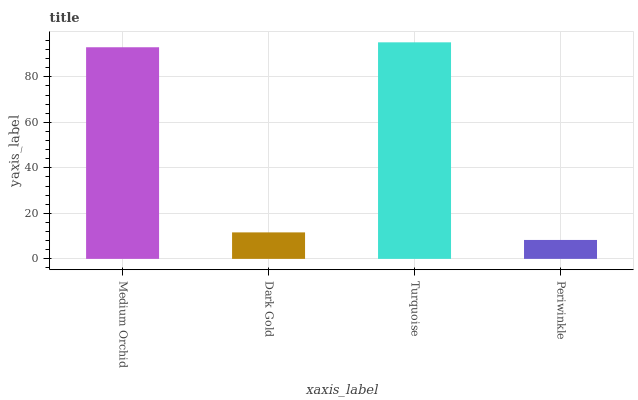Is Dark Gold the minimum?
Answer yes or no. No. Is Dark Gold the maximum?
Answer yes or no. No. Is Medium Orchid greater than Dark Gold?
Answer yes or no. Yes. Is Dark Gold less than Medium Orchid?
Answer yes or no. Yes. Is Dark Gold greater than Medium Orchid?
Answer yes or no. No. Is Medium Orchid less than Dark Gold?
Answer yes or no. No. Is Medium Orchid the high median?
Answer yes or no. Yes. Is Dark Gold the low median?
Answer yes or no. Yes. Is Periwinkle the high median?
Answer yes or no. No. Is Periwinkle the low median?
Answer yes or no. No. 